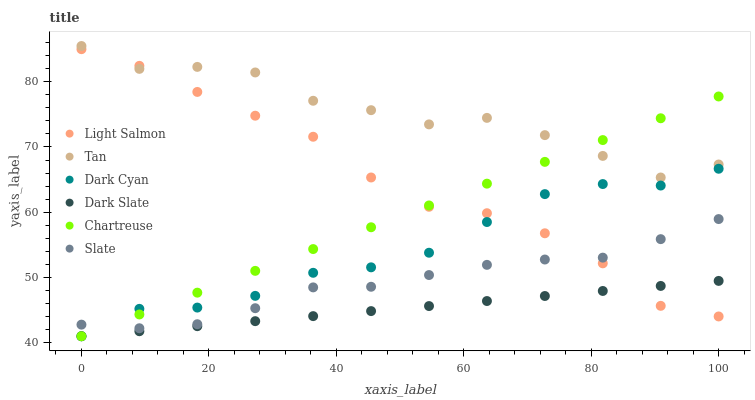Does Dark Slate have the minimum area under the curve?
Answer yes or no. Yes. Does Tan have the maximum area under the curve?
Answer yes or no. Yes. Does Slate have the minimum area under the curve?
Answer yes or no. No. Does Slate have the maximum area under the curve?
Answer yes or no. No. Is Chartreuse the smoothest?
Answer yes or no. Yes. Is Tan the roughest?
Answer yes or no. Yes. Is Slate the smoothest?
Answer yes or no. No. Is Slate the roughest?
Answer yes or no. No. Does Dark Slate have the lowest value?
Answer yes or no. Yes. Does Slate have the lowest value?
Answer yes or no. No. Does Tan have the highest value?
Answer yes or no. Yes. Does Slate have the highest value?
Answer yes or no. No. Is Slate less than Tan?
Answer yes or no. Yes. Is Slate greater than Dark Slate?
Answer yes or no. Yes. Does Light Salmon intersect Chartreuse?
Answer yes or no. Yes. Is Light Salmon less than Chartreuse?
Answer yes or no. No. Is Light Salmon greater than Chartreuse?
Answer yes or no. No. Does Slate intersect Tan?
Answer yes or no. No. 